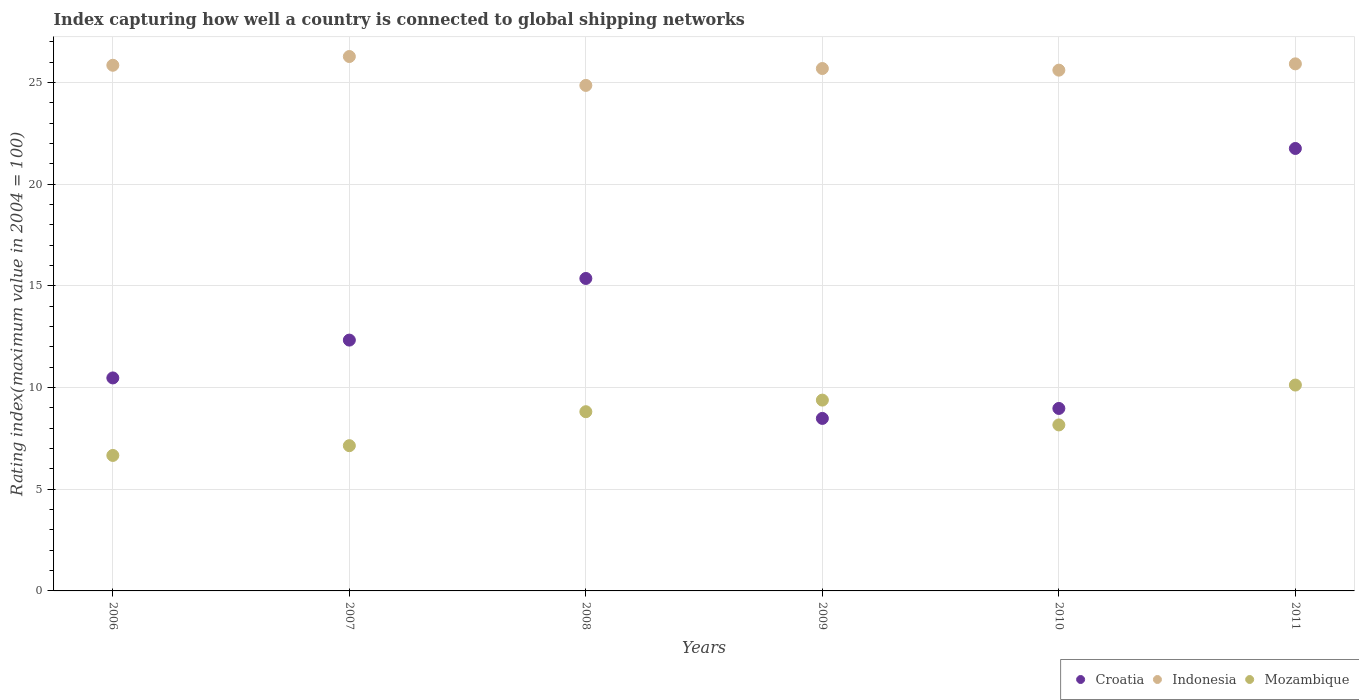What is the rating index in Croatia in 2006?
Offer a terse response. 10.47. Across all years, what is the maximum rating index in Indonesia?
Keep it short and to the point. 26.27. Across all years, what is the minimum rating index in Indonesia?
Keep it short and to the point. 24.85. In which year was the rating index in Croatia maximum?
Your answer should be compact. 2011. What is the total rating index in Indonesia in the graph?
Offer a terse response. 154.15. What is the difference between the rating index in Croatia in 2008 and that in 2009?
Make the answer very short. 6.88. What is the difference between the rating index in Croatia in 2011 and the rating index in Mozambique in 2008?
Offer a terse response. 12.94. What is the average rating index in Croatia per year?
Your answer should be very brief. 12.89. In the year 2008, what is the difference between the rating index in Indonesia and rating index in Croatia?
Your answer should be very brief. 9.49. In how many years, is the rating index in Indonesia greater than 15?
Give a very brief answer. 6. What is the ratio of the rating index in Croatia in 2006 to that in 2008?
Provide a short and direct response. 0.68. Is the difference between the rating index in Indonesia in 2008 and 2011 greater than the difference between the rating index in Croatia in 2008 and 2011?
Offer a terse response. Yes. What is the difference between the highest and the second highest rating index in Mozambique?
Provide a short and direct response. 0.74. What is the difference between the highest and the lowest rating index in Indonesia?
Offer a very short reply. 1.42. In how many years, is the rating index in Croatia greater than the average rating index in Croatia taken over all years?
Give a very brief answer. 2. Is the sum of the rating index in Mozambique in 2006 and 2007 greater than the maximum rating index in Indonesia across all years?
Your answer should be compact. No. Is the rating index in Croatia strictly greater than the rating index in Mozambique over the years?
Offer a very short reply. No. How many dotlines are there?
Make the answer very short. 3. What is the difference between two consecutive major ticks on the Y-axis?
Your answer should be compact. 5. Does the graph contain any zero values?
Provide a short and direct response. No. Where does the legend appear in the graph?
Make the answer very short. Bottom right. What is the title of the graph?
Your answer should be compact. Index capturing how well a country is connected to global shipping networks. Does "Trinidad and Tobago" appear as one of the legend labels in the graph?
Give a very brief answer. No. What is the label or title of the Y-axis?
Your response must be concise. Rating index(maximum value in 2004 = 100). What is the Rating index(maximum value in 2004 = 100) of Croatia in 2006?
Make the answer very short. 10.47. What is the Rating index(maximum value in 2004 = 100) in Indonesia in 2006?
Your answer should be compact. 25.84. What is the Rating index(maximum value in 2004 = 100) in Mozambique in 2006?
Offer a very short reply. 6.66. What is the Rating index(maximum value in 2004 = 100) of Croatia in 2007?
Keep it short and to the point. 12.33. What is the Rating index(maximum value in 2004 = 100) in Indonesia in 2007?
Provide a short and direct response. 26.27. What is the Rating index(maximum value in 2004 = 100) of Mozambique in 2007?
Provide a succinct answer. 7.14. What is the Rating index(maximum value in 2004 = 100) in Croatia in 2008?
Your answer should be compact. 15.36. What is the Rating index(maximum value in 2004 = 100) of Indonesia in 2008?
Your response must be concise. 24.85. What is the Rating index(maximum value in 2004 = 100) in Mozambique in 2008?
Provide a succinct answer. 8.81. What is the Rating index(maximum value in 2004 = 100) in Croatia in 2009?
Offer a very short reply. 8.48. What is the Rating index(maximum value in 2004 = 100) in Indonesia in 2009?
Make the answer very short. 25.68. What is the Rating index(maximum value in 2004 = 100) in Mozambique in 2009?
Your answer should be compact. 9.38. What is the Rating index(maximum value in 2004 = 100) in Croatia in 2010?
Your answer should be compact. 8.97. What is the Rating index(maximum value in 2004 = 100) of Indonesia in 2010?
Your answer should be compact. 25.6. What is the Rating index(maximum value in 2004 = 100) in Mozambique in 2010?
Provide a succinct answer. 8.16. What is the Rating index(maximum value in 2004 = 100) in Croatia in 2011?
Your answer should be compact. 21.75. What is the Rating index(maximum value in 2004 = 100) in Indonesia in 2011?
Offer a terse response. 25.91. What is the Rating index(maximum value in 2004 = 100) in Mozambique in 2011?
Offer a very short reply. 10.12. Across all years, what is the maximum Rating index(maximum value in 2004 = 100) of Croatia?
Your answer should be very brief. 21.75. Across all years, what is the maximum Rating index(maximum value in 2004 = 100) of Indonesia?
Offer a terse response. 26.27. Across all years, what is the maximum Rating index(maximum value in 2004 = 100) in Mozambique?
Your answer should be compact. 10.12. Across all years, what is the minimum Rating index(maximum value in 2004 = 100) of Croatia?
Your response must be concise. 8.48. Across all years, what is the minimum Rating index(maximum value in 2004 = 100) in Indonesia?
Give a very brief answer. 24.85. Across all years, what is the minimum Rating index(maximum value in 2004 = 100) in Mozambique?
Make the answer very short. 6.66. What is the total Rating index(maximum value in 2004 = 100) in Croatia in the graph?
Offer a terse response. 77.36. What is the total Rating index(maximum value in 2004 = 100) of Indonesia in the graph?
Your answer should be compact. 154.15. What is the total Rating index(maximum value in 2004 = 100) of Mozambique in the graph?
Provide a succinct answer. 50.27. What is the difference between the Rating index(maximum value in 2004 = 100) in Croatia in 2006 and that in 2007?
Offer a very short reply. -1.86. What is the difference between the Rating index(maximum value in 2004 = 100) in Indonesia in 2006 and that in 2007?
Offer a terse response. -0.43. What is the difference between the Rating index(maximum value in 2004 = 100) in Mozambique in 2006 and that in 2007?
Provide a short and direct response. -0.48. What is the difference between the Rating index(maximum value in 2004 = 100) in Croatia in 2006 and that in 2008?
Ensure brevity in your answer.  -4.89. What is the difference between the Rating index(maximum value in 2004 = 100) in Mozambique in 2006 and that in 2008?
Make the answer very short. -2.15. What is the difference between the Rating index(maximum value in 2004 = 100) of Croatia in 2006 and that in 2009?
Make the answer very short. 1.99. What is the difference between the Rating index(maximum value in 2004 = 100) in Indonesia in 2006 and that in 2009?
Your answer should be very brief. 0.16. What is the difference between the Rating index(maximum value in 2004 = 100) of Mozambique in 2006 and that in 2009?
Your answer should be very brief. -2.72. What is the difference between the Rating index(maximum value in 2004 = 100) of Croatia in 2006 and that in 2010?
Keep it short and to the point. 1.5. What is the difference between the Rating index(maximum value in 2004 = 100) of Indonesia in 2006 and that in 2010?
Provide a short and direct response. 0.24. What is the difference between the Rating index(maximum value in 2004 = 100) of Croatia in 2006 and that in 2011?
Offer a very short reply. -11.28. What is the difference between the Rating index(maximum value in 2004 = 100) in Indonesia in 2006 and that in 2011?
Your response must be concise. -0.07. What is the difference between the Rating index(maximum value in 2004 = 100) in Mozambique in 2006 and that in 2011?
Offer a very short reply. -3.46. What is the difference between the Rating index(maximum value in 2004 = 100) of Croatia in 2007 and that in 2008?
Offer a terse response. -3.03. What is the difference between the Rating index(maximum value in 2004 = 100) of Indonesia in 2007 and that in 2008?
Your response must be concise. 1.42. What is the difference between the Rating index(maximum value in 2004 = 100) of Mozambique in 2007 and that in 2008?
Offer a terse response. -1.67. What is the difference between the Rating index(maximum value in 2004 = 100) in Croatia in 2007 and that in 2009?
Make the answer very short. 3.85. What is the difference between the Rating index(maximum value in 2004 = 100) of Indonesia in 2007 and that in 2009?
Offer a terse response. 0.59. What is the difference between the Rating index(maximum value in 2004 = 100) of Mozambique in 2007 and that in 2009?
Keep it short and to the point. -2.24. What is the difference between the Rating index(maximum value in 2004 = 100) in Croatia in 2007 and that in 2010?
Make the answer very short. 3.36. What is the difference between the Rating index(maximum value in 2004 = 100) in Indonesia in 2007 and that in 2010?
Make the answer very short. 0.67. What is the difference between the Rating index(maximum value in 2004 = 100) in Mozambique in 2007 and that in 2010?
Give a very brief answer. -1.02. What is the difference between the Rating index(maximum value in 2004 = 100) of Croatia in 2007 and that in 2011?
Give a very brief answer. -9.42. What is the difference between the Rating index(maximum value in 2004 = 100) in Indonesia in 2007 and that in 2011?
Make the answer very short. 0.36. What is the difference between the Rating index(maximum value in 2004 = 100) in Mozambique in 2007 and that in 2011?
Offer a very short reply. -2.98. What is the difference between the Rating index(maximum value in 2004 = 100) in Croatia in 2008 and that in 2009?
Offer a terse response. 6.88. What is the difference between the Rating index(maximum value in 2004 = 100) of Indonesia in 2008 and that in 2009?
Make the answer very short. -0.83. What is the difference between the Rating index(maximum value in 2004 = 100) in Mozambique in 2008 and that in 2009?
Provide a short and direct response. -0.57. What is the difference between the Rating index(maximum value in 2004 = 100) of Croatia in 2008 and that in 2010?
Provide a succinct answer. 6.39. What is the difference between the Rating index(maximum value in 2004 = 100) of Indonesia in 2008 and that in 2010?
Your answer should be very brief. -0.75. What is the difference between the Rating index(maximum value in 2004 = 100) in Mozambique in 2008 and that in 2010?
Your answer should be compact. 0.65. What is the difference between the Rating index(maximum value in 2004 = 100) in Croatia in 2008 and that in 2011?
Your answer should be compact. -6.39. What is the difference between the Rating index(maximum value in 2004 = 100) in Indonesia in 2008 and that in 2011?
Make the answer very short. -1.06. What is the difference between the Rating index(maximum value in 2004 = 100) of Mozambique in 2008 and that in 2011?
Provide a short and direct response. -1.31. What is the difference between the Rating index(maximum value in 2004 = 100) of Croatia in 2009 and that in 2010?
Ensure brevity in your answer.  -0.49. What is the difference between the Rating index(maximum value in 2004 = 100) in Indonesia in 2009 and that in 2010?
Make the answer very short. 0.08. What is the difference between the Rating index(maximum value in 2004 = 100) of Mozambique in 2009 and that in 2010?
Give a very brief answer. 1.22. What is the difference between the Rating index(maximum value in 2004 = 100) in Croatia in 2009 and that in 2011?
Offer a terse response. -13.27. What is the difference between the Rating index(maximum value in 2004 = 100) of Indonesia in 2009 and that in 2011?
Keep it short and to the point. -0.23. What is the difference between the Rating index(maximum value in 2004 = 100) in Mozambique in 2009 and that in 2011?
Your answer should be very brief. -0.74. What is the difference between the Rating index(maximum value in 2004 = 100) of Croatia in 2010 and that in 2011?
Your response must be concise. -12.78. What is the difference between the Rating index(maximum value in 2004 = 100) in Indonesia in 2010 and that in 2011?
Offer a terse response. -0.31. What is the difference between the Rating index(maximum value in 2004 = 100) of Mozambique in 2010 and that in 2011?
Your response must be concise. -1.96. What is the difference between the Rating index(maximum value in 2004 = 100) of Croatia in 2006 and the Rating index(maximum value in 2004 = 100) of Indonesia in 2007?
Provide a succinct answer. -15.8. What is the difference between the Rating index(maximum value in 2004 = 100) in Croatia in 2006 and the Rating index(maximum value in 2004 = 100) in Mozambique in 2007?
Make the answer very short. 3.33. What is the difference between the Rating index(maximum value in 2004 = 100) in Croatia in 2006 and the Rating index(maximum value in 2004 = 100) in Indonesia in 2008?
Your answer should be very brief. -14.38. What is the difference between the Rating index(maximum value in 2004 = 100) in Croatia in 2006 and the Rating index(maximum value in 2004 = 100) in Mozambique in 2008?
Keep it short and to the point. 1.66. What is the difference between the Rating index(maximum value in 2004 = 100) of Indonesia in 2006 and the Rating index(maximum value in 2004 = 100) of Mozambique in 2008?
Keep it short and to the point. 17.03. What is the difference between the Rating index(maximum value in 2004 = 100) in Croatia in 2006 and the Rating index(maximum value in 2004 = 100) in Indonesia in 2009?
Provide a succinct answer. -15.21. What is the difference between the Rating index(maximum value in 2004 = 100) of Croatia in 2006 and the Rating index(maximum value in 2004 = 100) of Mozambique in 2009?
Offer a terse response. 1.09. What is the difference between the Rating index(maximum value in 2004 = 100) in Indonesia in 2006 and the Rating index(maximum value in 2004 = 100) in Mozambique in 2009?
Ensure brevity in your answer.  16.46. What is the difference between the Rating index(maximum value in 2004 = 100) of Croatia in 2006 and the Rating index(maximum value in 2004 = 100) of Indonesia in 2010?
Ensure brevity in your answer.  -15.13. What is the difference between the Rating index(maximum value in 2004 = 100) in Croatia in 2006 and the Rating index(maximum value in 2004 = 100) in Mozambique in 2010?
Make the answer very short. 2.31. What is the difference between the Rating index(maximum value in 2004 = 100) of Indonesia in 2006 and the Rating index(maximum value in 2004 = 100) of Mozambique in 2010?
Give a very brief answer. 17.68. What is the difference between the Rating index(maximum value in 2004 = 100) in Croatia in 2006 and the Rating index(maximum value in 2004 = 100) in Indonesia in 2011?
Provide a succinct answer. -15.44. What is the difference between the Rating index(maximum value in 2004 = 100) of Indonesia in 2006 and the Rating index(maximum value in 2004 = 100) of Mozambique in 2011?
Your answer should be very brief. 15.72. What is the difference between the Rating index(maximum value in 2004 = 100) of Croatia in 2007 and the Rating index(maximum value in 2004 = 100) of Indonesia in 2008?
Provide a short and direct response. -12.52. What is the difference between the Rating index(maximum value in 2004 = 100) of Croatia in 2007 and the Rating index(maximum value in 2004 = 100) of Mozambique in 2008?
Offer a very short reply. 3.52. What is the difference between the Rating index(maximum value in 2004 = 100) of Indonesia in 2007 and the Rating index(maximum value in 2004 = 100) of Mozambique in 2008?
Offer a very short reply. 17.46. What is the difference between the Rating index(maximum value in 2004 = 100) in Croatia in 2007 and the Rating index(maximum value in 2004 = 100) in Indonesia in 2009?
Your answer should be compact. -13.35. What is the difference between the Rating index(maximum value in 2004 = 100) of Croatia in 2007 and the Rating index(maximum value in 2004 = 100) of Mozambique in 2009?
Provide a succinct answer. 2.95. What is the difference between the Rating index(maximum value in 2004 = 100) in Indonesia in 2007 and the Rating index(maximum value in 2004 = 100) in Mozambique in 2009?
Offer a terse response. 16.89. What is the difference between the Rating index(maximum value in 2004 = 100) in Croatia in 2007 and the Rating index(maximum value in 2004 = 100) in Indonesia in 2010?
Make the answer very short. -13.27. What is the difference between the Rating index(maximum value in 2004 = 100) of Croatia in 2007 and the Rating index(maximum value in 2004 = 100) of Mozambique in 2010?
Make the answer very short. 4.17. What is the difference between the Rating index(maximum value in 2004 = 100) of Indonesia in 2007 and the Rating index(maximum value in 2004 = 100) of Mozambique in 2010?
Provide a short and direct response. 18.11. What is the difference between the Rating index(maximum value in 2004 = 100) in Croatia in 2007 and the Rating index(maximum value in 2004 = 100) in Indonesia in 2011?
Provide a succinct answer. -13.58. What is the difference between the Rating index(maximum value in 2004 = 100) of Croatia in 2007 and the Rating index(maximum value in 2004 = 100) of Mozambique in 2011?
Your answer should be very brief. 2.21. What is the difference between the Rating index(maximum value in 2004 = 100) in Indonesia in 2007 and the Rating index(maximum value in 2004 = 100) in Mozambique in 2011?
Provide a short and direct response. 16.15. What is the difference between the Rating index(maximum value in 2004 = 100) of Croatia in 2008 and the Rating index(maximum value in 2004 = 100) of Indonesia in 2009?
Keep it short and to the point. -10.32. What is the difference between the Rating index(maximum value in 2004 = 100) of Croatia in 2008 and the Rating index(maximum value in 2004 = 100) of Mozambique in 2009?
Provide a short and direct response. 5.98. What is the difference between the Rating index(maximum value in 2004 = 100) of Indonesia in 2008 and the Rating index(maximum value in 2004 = 100) of Mozambique in 2009?
Your answer should be very brief. 15.47. What is the difference between the Rating index(maximum value in 2004 = 100) of Croatia in 2008 and the Rating index(maximum value in 2004 = 100) of Indonesia in 2010?
Make the answer very short. -10.24. What is the difference between the Rating index(maximum value in 2004 = 100) of Croatia in 2008 and the Rating index(maximum value in 2004 = 100) of Mozambique in 2010?
Offer a very short reply. 7.2. What is the difference between the Rating index(maximum value in 2004 = 100) of Indonesia in 2008 and the Rating index(maximum value in 2004 = 100) of Mozambique in 2010?
Give a very brief answer. 16.69. What is the difference between the Rating index(maximum value in 2004 = 100) of Croatia in 2008 and the Rating index(maximum value in 2004 = 100) of Indonesia in 2011?
Provide a succinct answer. -10.55. What is the difference between the Rating index(maximum value in 2004 = 100) of Croatia in 2008 and the Rating index(maximum value in 2004 = 100) of Mozambique in 2011?
Offer a very short reply. 5.24. What is the difference between the Rating index(maximum value in 2004 = 100) in Indonesia in 2008 and the Rating index(maximum value in 2004 = 100) in Mozambique in 2011?
Make the answer very short. 14.73. What is the difference between the Rating index(maximum value in 2004 = 100) in Croatia in 2009 and the Rating index(maximum value in 2004 = 100) in Indonesia in 2010?
Keep it short and to the point. -17.12. What is the difference between the Rating index(maximum value in 2004 = 100) of Croatia in 2009 and the Rating index(maximum value in 2004 = 100) of Mozambique in 2010?
Make the answer very short. 0.32. What is the difference between the Rating index(maximum value in 2004 = 100) of Indonesia in 2009 and the Rating index(maximum value in 2004 = 100) of Mozambique in 2010?
Provide a short and direct response. 17.52. What is the difference between the Rating index(maximum value in 2004 = 100) in Croatia in 2009 and the Rating index(maximum value in 2004 = 100) in Indonesia in 2011?
Give a very brief answer. -17.43. What is the difference between the Rating index(maximum value in 2004 = 100) in Croatia in 2009 and the Rating index(maximum value in 2004 = 100) in Mozambique in 2011?
Offer a terse response. -1.64. What is the difference between the Rating index(maximum value in 2004 = 100) in Indonesia in 2009 and the Rating index(maximum value in 2004 = 100) in Mozambique in 2011?
Your answer should be compact. 15.56. What is the difference between the Rating index(maximum value in 2004 = 100) in Croatia in 2010 and the Rating index(maximum value in 2004 = 100) in Indonesia in 2011?
Your response must be concise. -16.94. What is the difference between the Rating index(maximum value in 2004 = 100) of Croatia in 2010 and the Rating index(maximum value in 2004 = 100) of Mozambique in 2011?
Give a very brief answer. -1.15. What is the difference between the Rating index(maximum value in 2004 = 100) of Indonesia in 2010 and the Rating index(maximum value in 2004 = 100) of Mozambique in 2011?
Offer a terse response. 15.48. What is the average Rating index(maximum value in 2004 = 100) in Croatia per year?
Offer a very short reply. 12.89. What is the average Rating index(maximum value in 2004 = 100) in Indonesia per year?
Provide a short and direct response. 25.69. What is the average Rating index(maximum value in 2004 = 100) in Mozambique per year?
Give a very brief answer. 8.38. In the year 2006, what is the difference between the Rating index(maximum value in 2004 = 100) of Croatia and Rating index(maximum value in 2004 = 100) of Indonesia?
Your answer should be compact. -15.37. In the year 2006, what is the difference between the Rating index(maximum value in 2004 = 100) in Croatia and Rating index(maximum value in 2004 = 100) in Mozambique?
Offer a terse response. 3.81. In the year 2006, what is the difference between the Rating index(maximum value in 2004 = 100) in Indonesia and Rating index(maximum value in 2004 = 100) in Mozambique?
Your answer should be compact. 19.18. In the year 2007, what is the difference between the Rating index(maximum value in 2004 = 100) of Croatia and Rating index(maximum value in 2004 = 100) of Indonesia?
Provide a short and direct response. -13.94. In the year 2007, what is the difference between the Rating index(maximum value in 2004 = 100) of Croatia and Rating index(maximum value in 2004 = 100) of Mozambique?
Your response must be concise. 5.19. In the year 2007, what is the difference between the Rating index(maximum value in 2004 = 100) of Indonesia and Rating index(maximum value in 2004 = 100) of Mozambique?
Your answer should be compact. 19.13. In the year 2008, what is the difference between the Rating index(maximum value in 2004 = 100) of Croatia and Rating index(maximum value in 2004 = 100) of Indonesia?
Provide a succinct answer. -9.49. In the year 2008, what is the difference between the Rating index(maximum value in 2004 = 100) in Croatia and Rating index(maximum value in 2004 = 100) in Mozambique?
Your response must be concise. 6.55. In the year 2008, what is the difference between the Rating index(maximum value in 2004 = 100) of Indonesia and Rating index(maximum value in 2004 = 100) of Mozambique?
Provide a succinct answer. 16.04. In the year 2009, what is the difference between the Rating index(maximum value in 2004 = 100) in Croatia and Rating index(maximum value in 2004 = 100) in Indonesia?
Provide a short and direct response. -17.2. In the year 2010, what is the difference between the Rating index(maximum value in 2004 = 100) in Croatia and Rating index(maximum value in 2004 = 100) in Indonesia?
Ensure brevity in your answer.  -16.63. In the year 2010, what is the difference between the Rating index(maximum value in 2004 = 100) in Croatia and Rating index(maximum value in 2004 = 100) in Mozambique?
Your answer should be very brief. 0.81. In the year 2010, what is the difference between the Rating index(maximum value in 2004 = 100) in Indonesia and Rating index(maximum value in 2004 = 100) in Mozambique?
Your answer should be very brief. 17.44. In the year 2011, what is the difference between the Rating index(maximum value in 2004 = 100) of Croatia and Rating index(maximum value in 2004 = 100) of Indonesia?
Ensure brevity in your answer.  -4.16. In the year 2011, what is the difference between the Rating index(maximum value in 2004 = 100) in Croatia and Rating index(maximum value in 2004 = 100) in Mozambique?
Make the answer very short. 11.63. In the year 2011, what is the difference between the Rating index(maximum value in 2004 = 100) in Indonesia and Rating index(maximum value in 2004 = 100) in Mozambique?
Your answer should be compact. 15.79. What is the ratio of the Rating index(maximum value in 2004 = 100) of Croatia in 2006 to that in 2007?
Offer a terse response. 0.85. What is the ratio of the Rating index(maximum value in 2004 = 100) of Indonesia in 2006 to that in 2007?
Your response must be concise. 0.98. What is the ratio of the Rating index(maximum value in 2004 = 100) in Mozambique in 2006 to that in 2007?
Provide a short and direct response. 0.93. What is the ratio of the Rating index(maximum value in 2004 = 100) in Croatia in 2006 to that in 2008?
Your answer should be compact. 0.68. What is the ratio of the Rating index(maximum value in 2004 = 100) of Indonesia in 2006 to that in 2008?
Provide a succinct answer. 1.04. What is the ratio of the Rating index(maximum value in 2004 = 100) in Mozambique in 2006 to that in 2008?
Provide a succinct answer. 0.76. What is the ratio of the Rating index(maximum value in 2004 = 100) in Croatia in 2006 to that in 2009?
Offer a very short reply. 1.23. What is the ratio of the Rating index(maximum value in 2004 = 100) of Indonesia in 2006 to that in 2009?
Your answer should be compact. 1.01. What is the ratio of the Rating index(maximum value in 2004 = 100) in Mozambique in 2006 to that in 2009?
Your answer should be compact. 0.71. What is the ratio of the Rating index(maximum value in 2004 = 100) in Croatia in 2006 to that in 2010?
Your response must be concise. 1.17. What is the ratio of the Rating index(maximum value in 2004 = 100) of Indonesia in 2006 to that in 2010?
Your answer should be compact. 1.01. What is the ratio of the Rating index(maximum value in 2004 = 100) in Mozambique in 2006 to that in 2010?
Your response must be concise. 0.82. What is the ratio of the Rating index(maximum value in 2004 = 100) of Croatia in 2006 to that in 2011?
Keep it short and to the point. 0.48. What is the ratio of the Rating index(maximum value in 2004 = 100) of Mozambique in 2006 to that in 2011?
Ensure brevity in your answer.  0.66. What is the ratio of the Rating index(maximum value in 2004 = 100) of Croatia in 2007 to that in 2008?
Provide a succinct answer. 0.8. What is the ratio of the Rating index(maximum value in 2004 = 100) in Indonesia in 2007 to that in 2008?
Your answer should be very brief. 1.06. What is the ratio of the Rating index(maximum value in 2004 = 100) in Mozambique in 2007 to that in 2008?
Provide a short and direct response. 0.81. What is the ratio of the Rating index(maximum value in 2004 = 100) in Croatia in 2007 to that in 2009?
Your response must be concise. 1.45. What is the ratio of the Rating index(maximum value in 2004 = 100) in Indonesia in 2007 to that in 2009?
Your answer should be very brief. 1.02. What is the ratio of the Rating index(maximum value in 2004 = 100) in Mozambique in 2007 to that in 2009?
Your answer should be very brief. 0.76. What is the ratio of the Rating index(maximum value in 2004 = 100) of Croatia in 2007 to that in 2010?
Your answer should be very brief. 1.37. What is the ratio of the Rating index(maximum value in 2004 = 100) of Indonesia in 2007 to that in 2010?
Give a very brief answer. 1.03. What is the ratio of the Rating index(maximum value in 2004 = 100) of Croatia in 2007 to that in 2011?
Your answer should be very brief. 0.57. What is the ratio of the Rating index(maximum value in 2004 = 100) in Indonesia in 2007 to that in 2011?
Offer a very short reply. 1.01. What is the ratio of the Rating index(maximum value in 2004 = 100) in Mozambique in 2007 to that in 2011?
Offer a very short reply. 0.71. What is the ratio of the Rating index(maximum value in 2004 = 100) in Croatia in 2008 to that in 2009?
Provide a short and direct response. 1.81. What is the ratio of the Rating index(maximum value in 2004 = 100) of Indonesia in 2008 to that in 2009?
Your response must be concise. 0.97. What is the ratio of the Rating index(maximum value in 2004 = 100) of Mozambique in 2008 to that in 2009?
Offer a very short reply. 0.94. What is the ratio of the Rating index(maximum value in 2004 = 100) of Croatia in 2008 to that in 2010?
Your answer should be compact. 1.71. What is the ratio of the Rating index(maximum value in 2004 = 100) in Indonesia in 2008 to that in 2010?
Provide a short and direct response. 0.97. What is the ratio of the Rating index(maximum value in 2004 = 100) of Mozambique in 2008 to that in 2010?
Ensure brevity in your answer.  1.08. What is the ratio of the Rating index(maximum value in 2004 = 100) of Croatia in 2008 to that in 2011?
Provide a succinct answer. 0.71. What is the ratio of the Rating index(maximum value in 2004 = 100) in Indonesia in 2008 to that in 2011?
Make the answer very short. 0.96. What is the ratio of the Rating index(maximum value in 2004 = 100) in Mozambique in 2008 to that in 2011?
Keep it short and to the point. 0.87. What is the ratio of the Rating index(maximum value in 2004 = 100) of Croatia in 2009 to that in 2010?
Offer a very short reply. 0.95. What is the ratio of the Rating index(maximum value in 2004 = 100) of Indonesia in 2009 to that in 2010?
Your answer should be compact. 1. What is the ratio of the Rating index(maximum value in 2004 = 100) in Mozambique in 2009 to that in 2010?
Make the answer very short. 1.15. What is the ratio of the Rating index(maximum value in 2004 = 100) in Croatia in 2009 to that in 2011?
Your answer should be very brief. 0.39. What is the ratio of the Rating index(maximum value in 2004 = 100) of Indonesia in 2009 to that in 2011?
Keep it short and to the point. 0.99. What is the ratio of the Rating index(maximum value in 2004 = 100) of Mozambique in 2009 to that in 2011?
Provide a short and direct response. 0.93. What is the ratio of the Rating index(maximum value in 2004 = 100) of Croatia in 2010 to that in 2011?
Your answer should be very brief. 0.41. What is the ratio of the Rating index(maximum value in 2004 = 100) in Indonesia in 2010 to that in 2011?
Provide a short and direct response. 0.99. What is the ratio of the Rating index(maximum value in 2004 = 100) of Mozambique in 2010 to that in 2011?
Your answer should be compact. 0.81. What is the difference between the highest and the second highest Rating index(maximum value in 2004 = 100) in Croatia?
Offer a terse response. 6.39. What is the difference between the highest and the second highest Rating index(maximum value in 2004 = 100) of Indonesia?
Ensure brevity in your answer.  0.36. What is the difference between the highest and the second highest Rating index(maximum value in 2004 = 100) in Mozambique?
Provide a succinct answer. 0.74. What is the difference between the highest and the lowest Rating index(maximum value in 2004 = 100) in Croatia?
Provide a short and direct response. 13.27. What is the difference between the highest and the lowest Rating index(maximum value in 2004 = 100) in Indonesia?
Ensure brevity in your answer.  1.42. What is the difference between the highest and the lowest Rating index(maximum value in 2004 = 100) in Mozambique?
Provide a succinct answer. 3.46. 